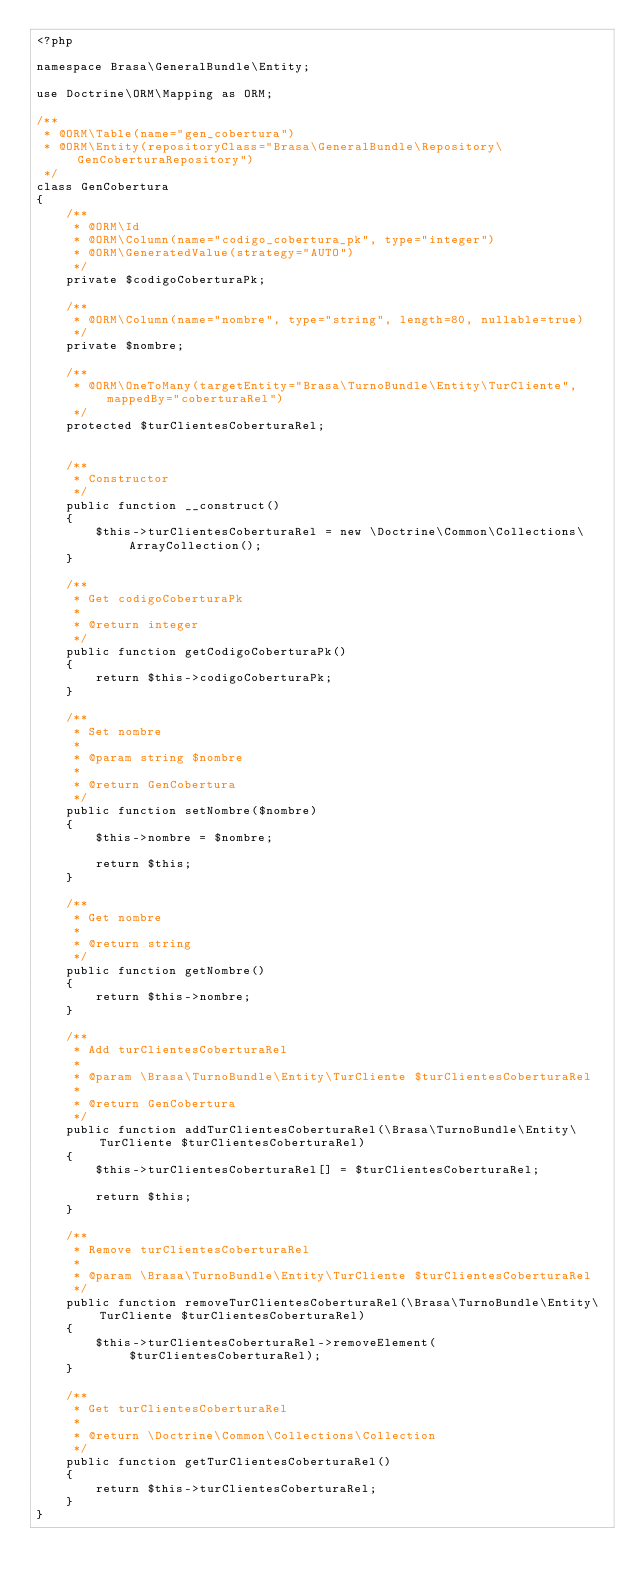<code> <loc_0><loc_0><loc_500><loc_500><_PHP_><?php

namespace Brasa\GeneralBundle\Entity;

use Doctrine\ORM\Mapping as ORM;

/**
 * @ORM\Table(name="gen_cobertura")
 * @ORM\Entity(repositoryClass="Brasa\GeneralBundle\Repository\GenCoberturaRepository")
 */
class GenCobertura
{
    /**
     * @ORM\Id
     * @ORM\Column(name="codigo_cobertura_pk", type="integer")
     * @ORM\GeneratedValue(strategy="AUTO")
     */ 
    private $codigoCoberturaPk;     
    
    /**
     * @ORM\Column(name="nombre", type="string", length=80, nullable=true)
     */      
    private $nombre;

    /**
     * @ORM\OneToMany(targetEntity="Brasa\TurnoBundle\Entity\TurCliente", mappedBy="coberturaRel")
     */
    protected $turClientesCoberturaRel;    
    

    /**
     * Constructor
     */
    public function __construct()
    {
        $this->turClientesCoberturaRel = new \Doctrine\Common\Collections\ArrayCollection();
    }

    /**
     * Get codigoCoberturaPk
     *
     * @return integer
     */
    public function getCodigoCoberturaPk()
    {
        return $this->codigoCoberturaPk;
    }

    /**
     * Set nombre
     *
     * @param string $nombre
     *
     * @return GenCobertura
     */
    public function setNombre($nombre)
    {
        $this->nombre = $nombre;

        return $this;
    }

    /**
     * Get nombre
     *
     * @return string
     */
    public function getNombre()
    {
        return $this->nombre;
    }

    /**
     * Add turClientesCoberturaRel
     *
     * @param \Brasa\TurnoBundle\Entity\TurCliente $turClientesCoberturaRel
     *
     * @return GenCobertura
     */
    public function addTurClientesCoberturaRel(\Brasa\TurnoBundle\Entity\TurCliente $turClientesCoberturaRel)
    {
        $this->turClientesCoberturaRel[] = $turClientesCoberturaRel;

        return $this;
    }

    /**
     * Remove turClientesCoberturaRel
     *
     * @param \Brasa\TurnoBundle\Entity\TurCliente $turClientesCoberturaRel
     */
    public function removeTurClientesCoberturaRel(\Brasa\TurnoBundle\Entity\TurCliente $turClientesCoberturaRel)
    {
        $this->turClientesCoberturaRel->removeElement($turClientesCoberturaRel);
    }

    /**
     * Get turClientesCoberturaRel
     *
     * @return \Doctrine\Common\Collections\Collection
     */
    public function getTurClientesCoberturaRel()
    {
        return $this->turClientesCoberturaRel;
    }
}
</code> 